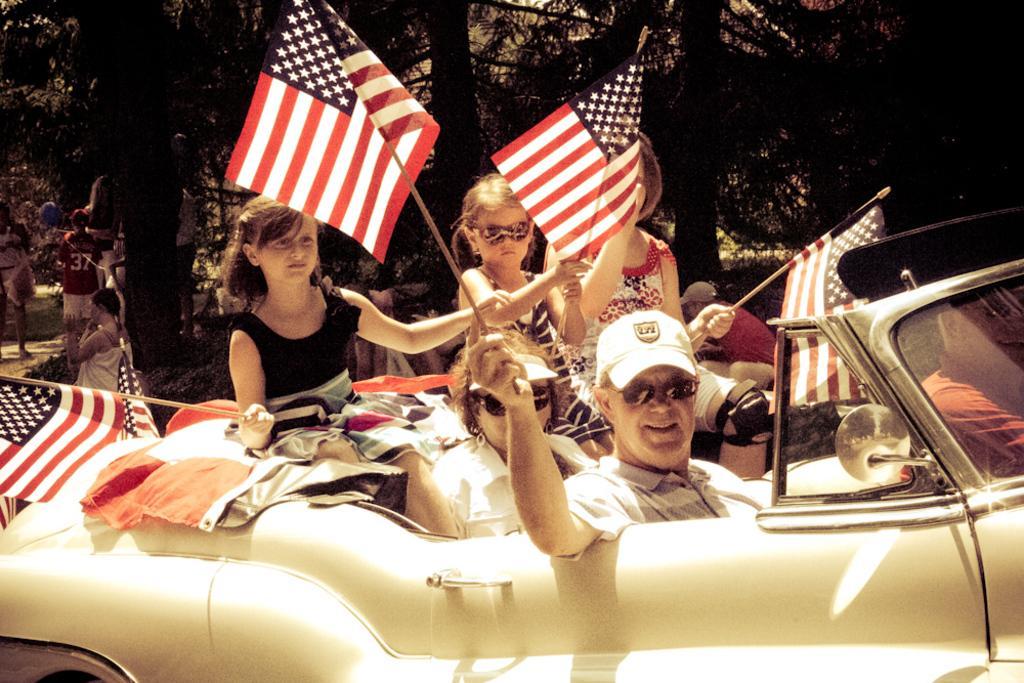In one or two sentences, can you explain what this image depicts? In this image i can see group of people some are playing with a ball and some are travelling in the car. The people travelling in the car they are holding the flags. There are three children one man and woman in the car, the man and women travelling in the car having the shades and the man having the cap. At the back i can see a tree. 